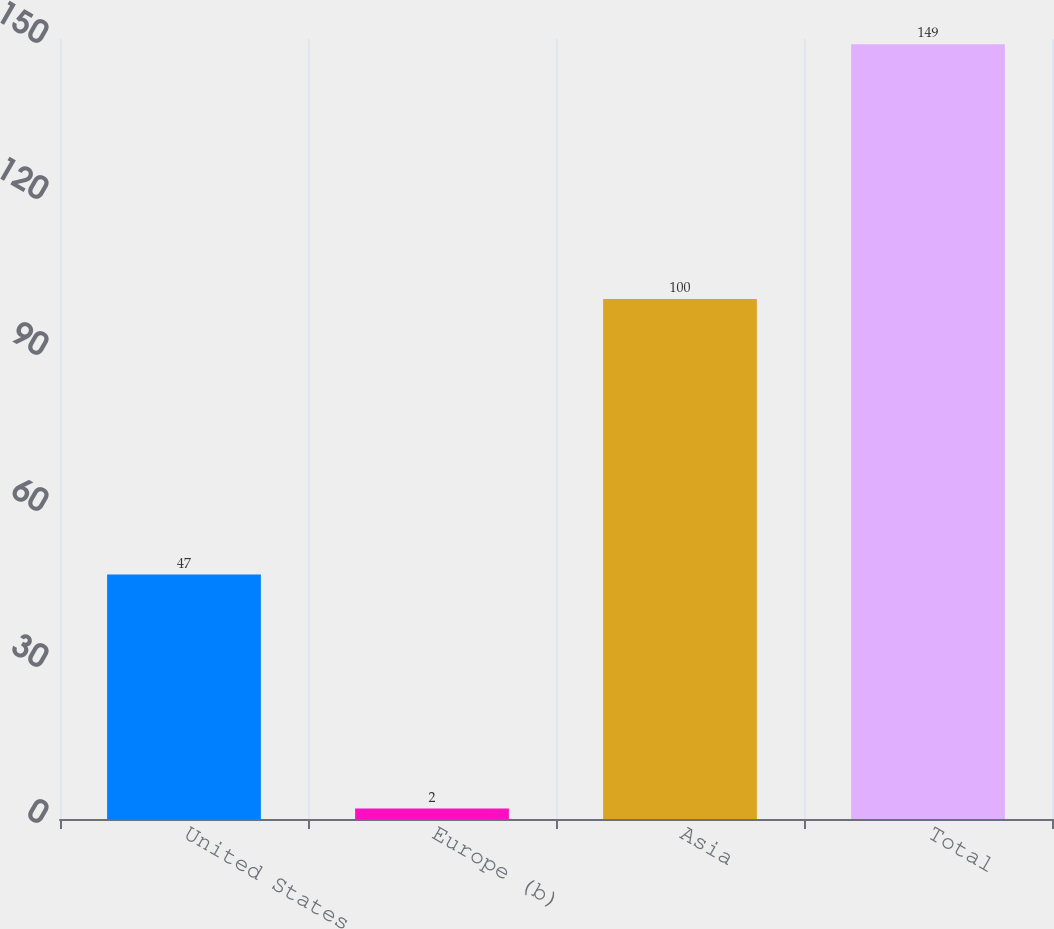Convert chart. <chart><loc_0><loc_0><loc_500><loc_500><bar_chart><fcel>United States<fcel>Europe (b)<fcel>Asia<fcel>Total<nl><fcel>47<fcel>2<fcel>100<fcel>149<nl></chart> 